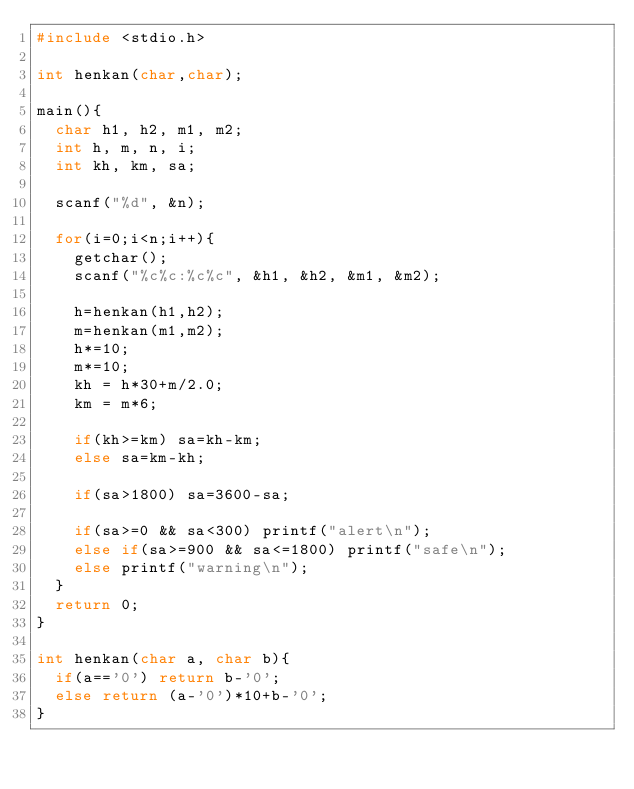Convert code to text. <code><loc_0><loc_0><loc_500><loc_500><_C_>#include <stdio.h>

int henkan(char,char);

main(){
  char h1, h2, m1, m2;
  int h, m, n, i;
  int kh, km, sa;

  scanf("%d", &n);

  for(i=0;i<n;i++){
    getchar();
    scanf("%c%c:%c%c", &h1, &h2, &m1, &m2);

    h=henkan(h1,h2);
    m=henkan(m1,m2);
    h*=10;
    m*=10;
    kh = h*30+m/2.0;
    km = m*6;

    if(kh>=km) sa=kh-km;
    else sa=km-kh;

    if(sa>1800) sa=3600-sa;

    if(sa>=0 && sa<300) printf("alert\n");
    else if(sa>=900 && sa<=1800) printf("safe\n");
    else printf("warning\n");
  }
  return 0;
}

int henkan(char a, char b){
  if(a=='0') return b-'0';
  else return (a-'0')*10+b-'0';
}</code> 